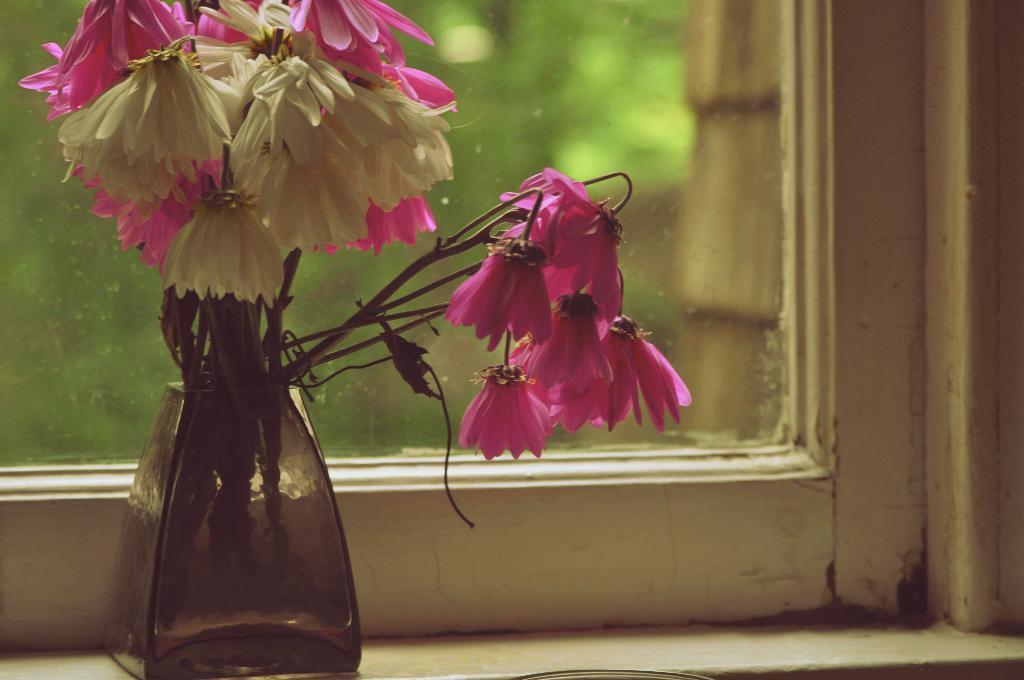In one or two sentences, can you explain what this image depicts? In this image I can see the flower vase and I can see the flowers are in pink and white color. In the background I can see the window. 